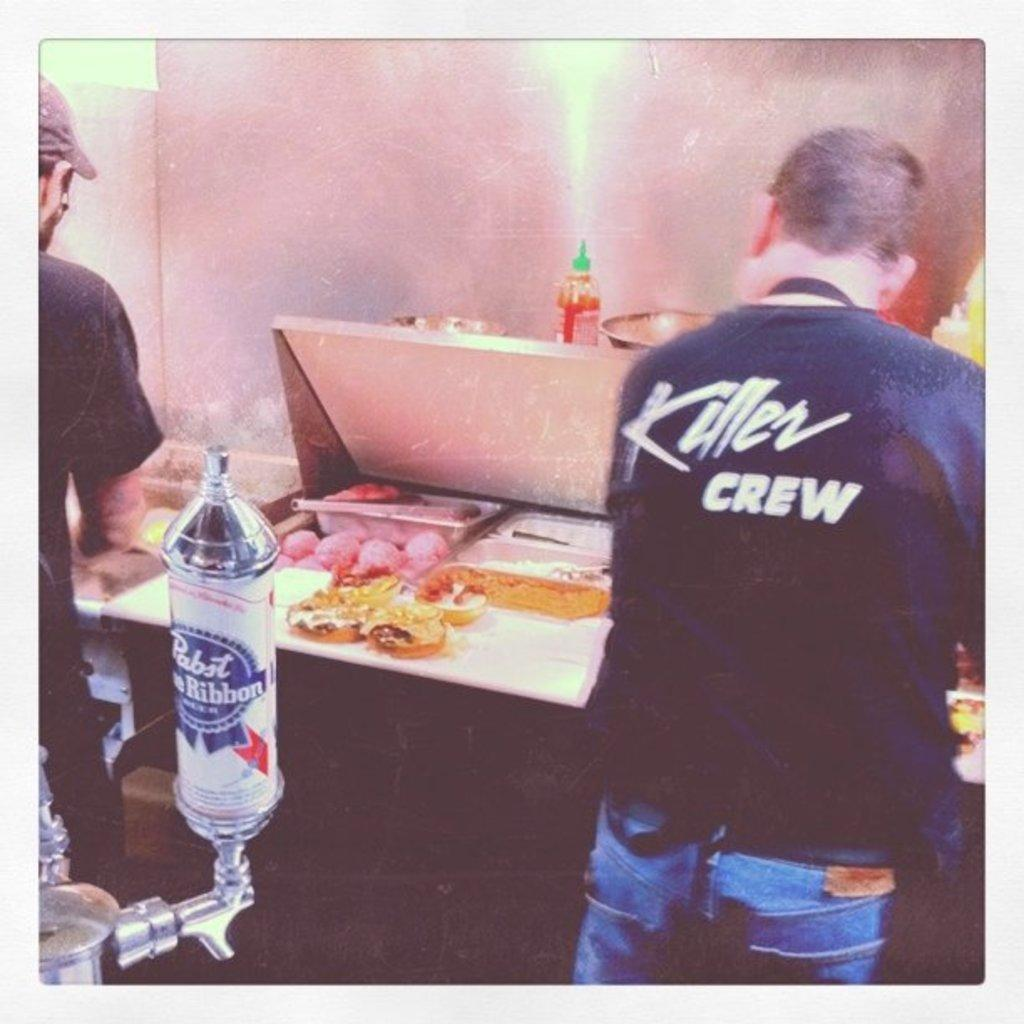How many people are in the image? There are two men in the image. What are the men doing in the image? The men are standing beside a table. What can be found on the table in the image? There is food, a bottle, and bowls on the table. Where is the container located in the image? There is a container on the left side of the image. What type of statement is being made by the goose in the image? There is no goose present in the image, so no statement can be attributed to a goose. How many clovers are visible on the table in the image? There are no clovers visible on the table in the image. 